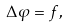Convert formula to latex. <formula><loc_0><loc_0><loc_500><loc_500>\Delta \varphi = f ,</formula> 